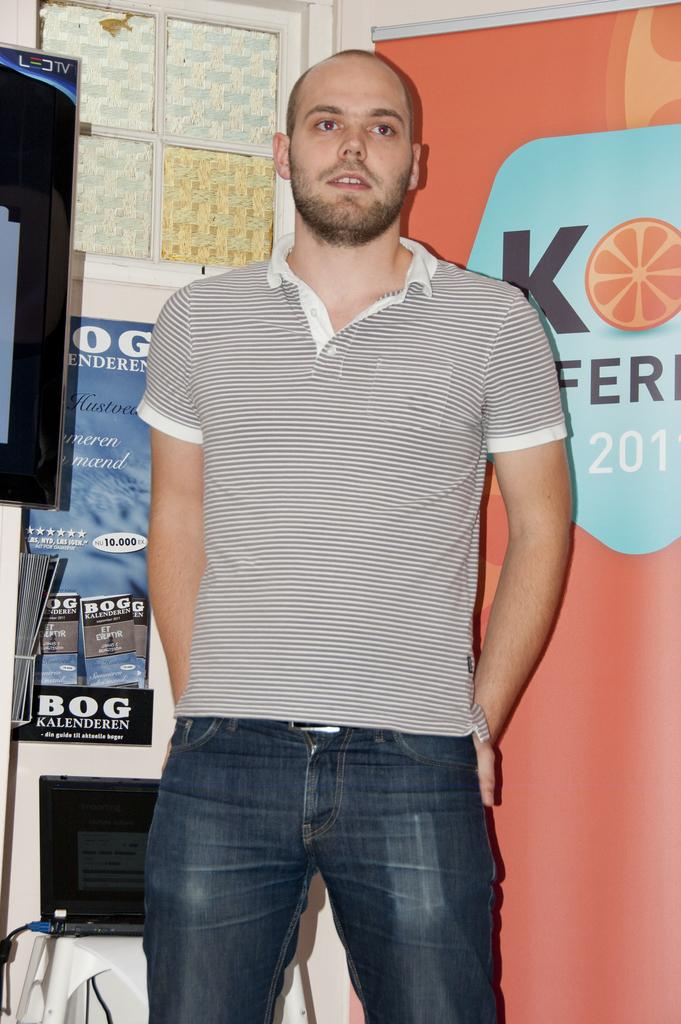What is the main subject in the image? There is a man standing in the image. What can be seen behind the man? There is a window behind the man. What other objects are present in the image? There is a banner, a poster, a laptop, and a television in the image. What type of spoon is the man using to play music in the image? There is no spoon or music present in the image. 